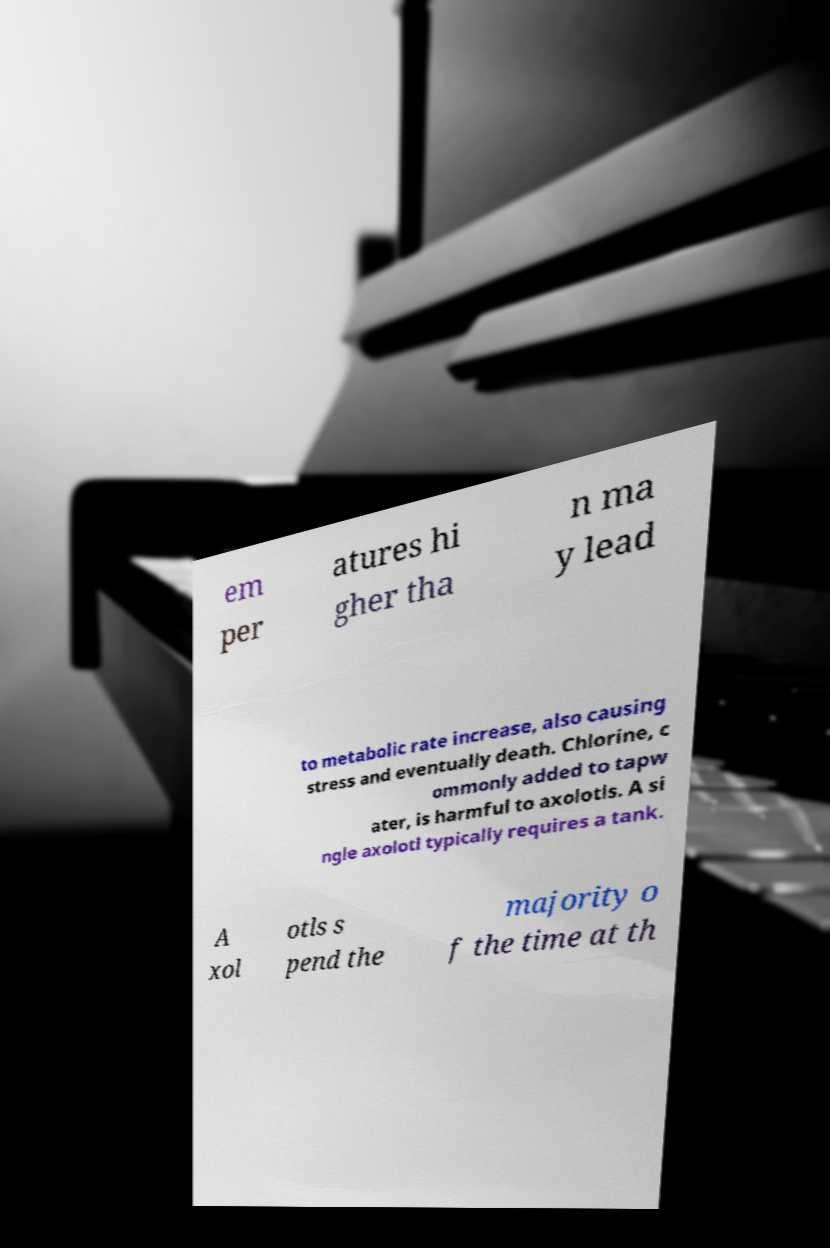Can you read and provide the text displayed in the image?This photo seems to have some interesting text. Can you extract and type it out for me? em per atures hi gher tha n ma y lead to metabolic rate increase, also causing stress and eventually death. Chlorine, c ommonly added to tapw ater, is harmful to axolotls. A si ngle axolotl typically requires a tank. A xol otls s pend the majority o f the time at th 